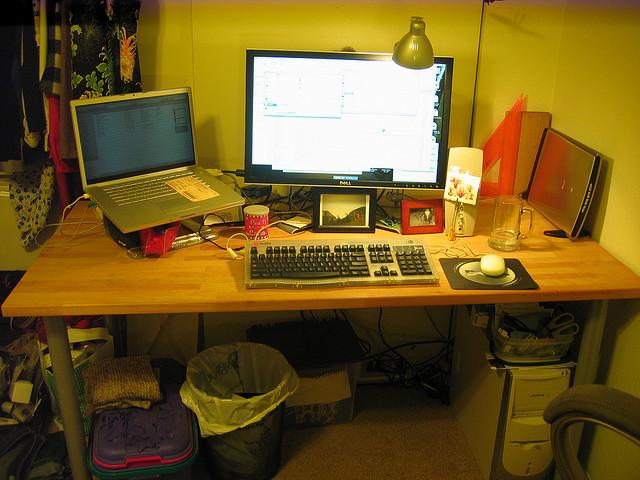What kind of cup is sat on the desk next to the computer mouse?

Choices:
A) glass
B) wine glass
C) tea cup
D) mug mug 